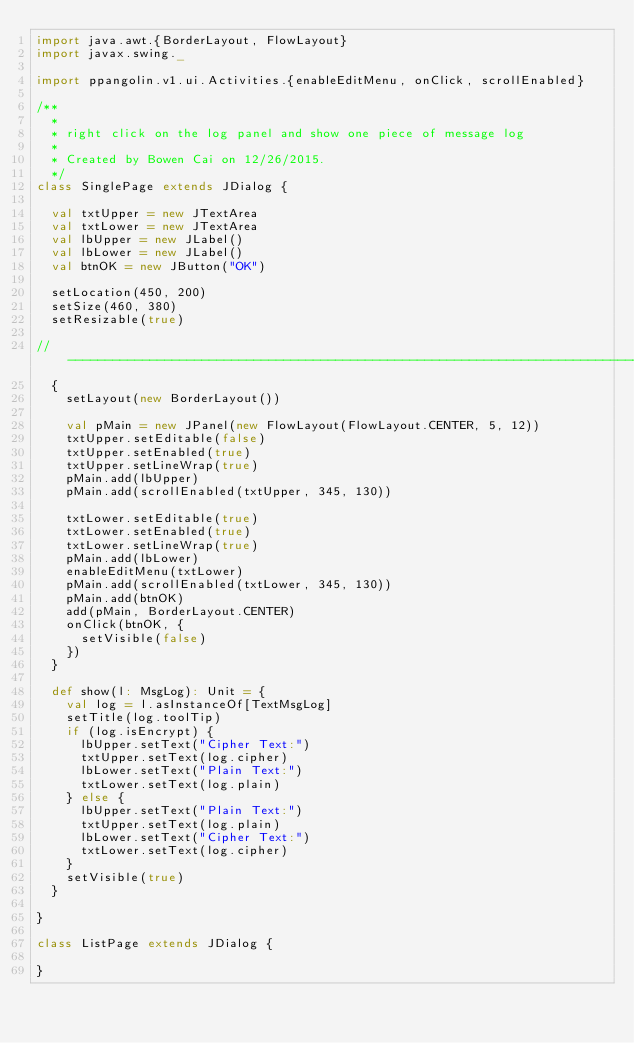Convert code to text. <code><loc_0><loc_0><loc_500><loc_500><_Scala_>import java.awt.{BorderLayout, FlowLayout}
import javax.swing._

import ppangolin.v1.ui.Activities.{enableEditMenu, onClick, scrollEnabled}

/**
  *
  * right click on the log panel and show one piece of message log
  *
  * Created by Bowen Cai on 12/26/2015.
  */
class SinglePage extends JDialog {

  val txtUpper = new JTextArea
  val txtLower = new JTextArea
  val lbUpper = new JLabel()
  val lbLower = new JLabel()
  val btnOK = new JButton("OK")

  setLocation(450, 200)
  setSize(460, 380)
  setResizable(true)

//-----------------------------------------------------------------------------
  {
    setLayout(new BorderLayout())

    val pMain = new JPanel(new FlowLayout(FlowLayout.CENTER, 5, 12))
    txtUpper.setEditable(false)
    txtUpper.setEnabled(true)
    txtUpper.setLineWrap(true)
    pMain.add(lbUpper)
    pMain.add(scrollEnabled(txtUpper, 345, 130))

    txtLower.setEditable(true)
    txtLower.setEnabled(true)
    txtLower.setLineWrap(true)
    pMain.add(lbLower)
    enableEditMenu(txtLower)
    pMain.add(scrollEnabled(txtLower, 345, 130))
    pMain.add(btnOK)
    add(pMain, BorderLayout.CENTER)
    onClick(btnOK, {
      setVisible(false)
    })
  }

  def show(l: MsgLog): Unit = {
    val log = l.asInstanceOf[TextMsgLog]
    setTitle(log.toolTip)
    if (log.isEncrypt) {
      lbUpper.setText("Cipher Text:")
      txtUpper.setText(log.cipher)
      lbLower.setText("Plain Text:")
      txtLower.setText(log.plain)
    } else {
      lbUpper.setText("Plain Text:")
      txtUpper.setText(log.plain)
      lbLower.setText("Cipher Text:")
      txtLower.setText(log.cipher)
    }
    setVisible(true)
  }

}

class ListPage extends JDialog {

}</code> 